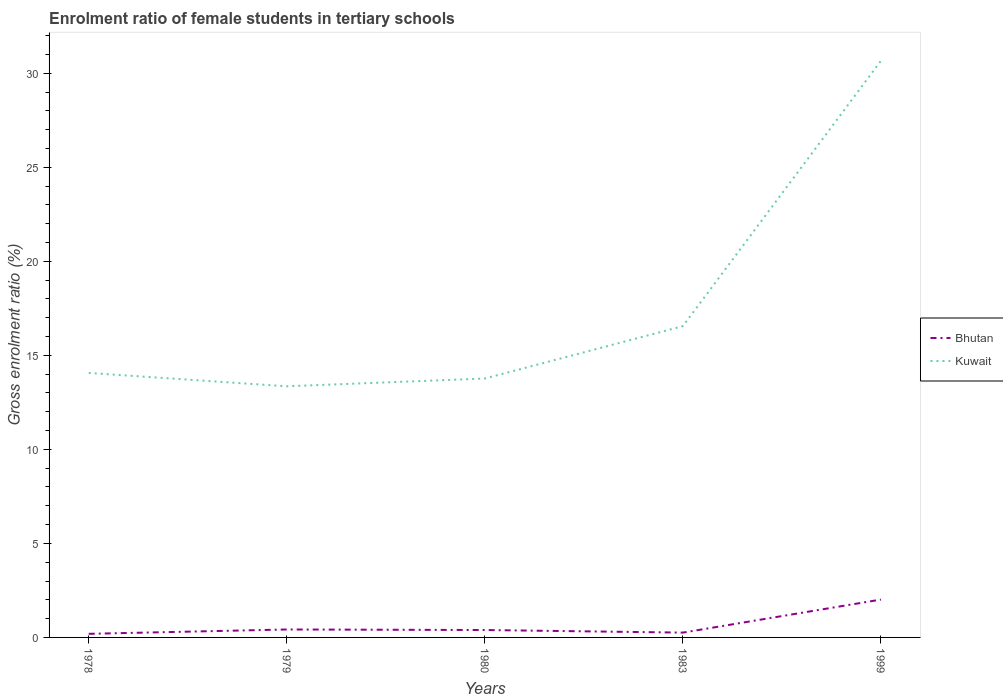How many different coloured lines are there?
Give a very brief answer. 2. Does the line corresponding to Bhutan intersect with the line corresponding to Kuwait?
Your answer should be very brief. No. Is the number of lines equal to the number of legend labels?
Ensure brevity in your answer.  Yes. Across all years, what is the maximum enrolment ratio of female students in tertiary schools in Bhutan?
Keep it short and to the point. 0.19. In which year was the enrolment ratio of female students in tertiary schools in Kuwait maximum?
Give a very brief answer. 1979. What is the total enrolment ratio of female students in tertiary schools in Kuwait in the graph?
Provide a short and direct response. -14.11. What is the difference between the highest and the second highest enrolment ratio of female students in tertiary schools in Bhutan?
Offer a terse response. 1.82. What is the difference between the highest and the lowest enrolment ratio of female students in tertiary schools in Bhutan?
Ensure brevity in your answer.  1. How many lines are there?
Your answer should be compact. 2. What is the difference between two consecutive major ticks on the Y-axis?
Provide a succinct answer. 5. Are the values on the major ticks of Y-axis written in scientific E-notation?
Offer a very short reply. No. Does the graph contain any zero values?
Provide a succinct answer. No. Does the graph contain grids?
Offer a terse response. No. How are the legend labels stacked?
Offer a very short reply. Vertical. What is the title of the graph?
Make the answer very short. Enrolment ratio of female students in tertiary schools. What is the label or title of the X-axis?
Give a very brief answer. Years. What is the Gross enrolment ratio (%) of Bhutan in 1978?
Offer a very short reply. 0.19. What is the Gross enrolment ratio (%) in Kuwait in 1978?
Offer a very short reply. 14.06. What is the Gross enrolment ratio (%) of Bhutan in 1979?
Give a very brief answer. 0.42. What is the Gross enrolment ratio (%) in Kuwait in 1979?
Offer a terse response. 13.35. What is the Gross enrolment ratio (%) of Bhutan in 1980?
Keep it short and to the point. 0.39. What is the Gross enrolment ratio (%) of Kuwait in 1980?
Offer a very short reply. 13.77. What is the Gross enrolment ratio (%) in Bhutan in 1983?
Ensure brevity in your answer.  0.26. What is the Gross enrolment ratio (%) of Kuwait in 1983?
Your answer should be compact. 16.55. What is the Gross enrolment ratio (%) in Bhutan in 1999?
Provide a short and direct response. 2.01. What is the Gross enrolment ratio (%) of Kuwait in 1999?
Keep it short and to the point. 30.66. Across all years, what is the maximum Gross enrolment ratio (%) of Bhutan?
Make the answer very short. 2.01. Across all years, what is the maximum Gross enrolment ratio (%) of Kuwait?
Keep it short and to the point. 30.66. Across all years, what is the minimum Gross enrolment ratio (%) in Bhutan?
Make the answer very short. 0.19. Across all years, what is the minimum Gross enrolment ratio (%) in Kuwait?
Provide a succinct answer. 13.35. What is the total Gross enrolment ratio (%) of Bhutan in the graph?
Your response must be concise. 3.28. What is the total Gross enrolment ratio (%) of Kuwait in the graph?
Offer a terse response. 88.4. What is the difference between the Gross enrolment ratio (%) in Bhutan in 1978 and that in 1979?
Your response must be concise. -0.23. What is the difference between the Gross enrolment ratio (%) of Kuwait in 1978 and that in 1979?
Provide a succinct answer. 0.71. What is the difference between the Gross enrolment ratio (%) in Bhutan in 1978 and that in 1980?
Your answer should be compact. -0.2. What is the difference between the Gross enrolment ratio (%) in Kuwait in 1978 and that in 1980?
Make the answer very short. 0.3. What is the difference between the Gross enrolment ratio (%) in Bhutan in 1978 and that in 1983?
Your answer should be very brief. -0.06. What is the difference between the Gross enrolment ratio (%) in Kuwait in 1978 and that in 1983?
Give a very brief answer. -2.49. What is the difference between the Gross enrolment ratio (%) in Bhutan in 1978 and that in 1999?
Give a very brief answer. -1.82. What is the difference between the Gross enrolment ratio (%) in Kuwait in 1978 and that in 1999?
Provide a succinct answer. -16.59. What is the difference between the Gross enrolment ratio (%) of Bhutan in 1979 and that in 1980?
Your answer should be compact. 0.03. What is the difference between the Gross enrolment ratio (%) in Kuwait in 1979 and that in 1980?
Your answer should be very brief. -0.41. What is the difference between the Gross enrolment ratio (%) in Bhutan in 1979 and that in 1983?
Provide a short and direct response. 0.17. What is the difference between the Gross enrolment ratio (%) in Kuwait in 1979 and that in 1983?
Offer a terse response. -3.2. What is the difference between the Gross enrolment ratio (%) of Bhutan in 1979 and that in 1999?
Offer a very short reply. -1.59. What is the difference between the Gross enrolment ratio (%) in Kuwait in 1979 and that in 1999?
Make the answer very short. -17.3. What is the difference between the Gross enrolment ratio (%) of Bhutan in 1980 and that in 1983?
Provide a succinct answer. 0.14. What is the difference between the Gross enrolment ratio (%) in Kuwait in 1980 and that in 1983?
Provide a succinct answer. -2.79. What is the difference between the Gross enrolment ratio (%) of Bhutan in 1980 and that in 1999?
Your answer should be compact. -1.62. What is the difference between the Gross enrolment ratio (%) of Kuwait in 1980 and that in 1999?
Provide a succinct answer. -16.89. What is the difference between the Gross enrolment ratio (%) in Bhutan in 1983 and that in 1999?
Your response must be concise. -1.76. What is the difference between the Gross enrolment ratio (%) in Kuwait in 1983 and that in 1999?
Provide a succinct answer. -14.11. What is the difference between the Gross enrolment ratio (%) in Bhutan in 1978 and the Gross enrolment ratio (%) in Kuwait in 1979?
Your answer should be compact. -13.16. What is the difference between the Gross enrolment ratio (%) of Bhutan in 1978 and the Gross enrolment ratio (%) of Kuwait in 1980?
Your answer should be very brief. -13.58. What is the difference between the Gross enrolment ratio (%) of Bhutan in 1978 and the Gross enrolment ratio (%) of Kuwait in 1983?
Provide a succinct answer. -16.36. What is the difference between the Gross enrolment ratio (%) in Bhutan in 1978 and the Gross enrolment ratio (%) in Kuwait in 1999?
Offer a very short reply. -30.47. What is the difference between the Gross enrolment ratio (%) of Bhutan in 1979 and the Gross enrolment ratio (%) of Kuwait in 1980?
Keep it short and to the point. -13.35. What is the difference between the Gross enrolment ratio (%) of Bhutan in 1979 and the Gross enrolment ratio (%) of Kuwait in 1983?
Your response must be concise. -16.13. What is the difference between the Gross enrolment ratio (%) of Bhutan in 1979 and the Gross enrolment ratio (%) of Kuwait in 1999?
Your answer should be compact. -30.24. What is the difference between the Gross enrolment ratio (%) in Bhutan in 1980 and the Gross enrolment ratio (%) in Kuwait in 1983?
Your answer should be compact. -16.16. What is the difference between the Gross enrolment ratio (%) in Bhutan in 1980 and the Gross enrolment ratio (%) in Kuwait in 1999?
Your answer should be compact. -30.26. What is the difference between the Gross enrolment ratio (%) of Bhutan in 1983 and the Gross enrolment ratio (%) of Kuwait in 1999?
Your response must be concise. -30.4. What is the average Gross enrolment ratio (%) of Bhutan per year?
Offer a terse response. 0.66. What is the average Gross enrolment ratio (%) of Kuwait per year?
Your response must be concise. 17.68. In the year 1978, what is the difference between the Gross enrolment ratio (%) in Bhutan and Gross enrolment ratio (%) in Kuwait?
Offer a terse response. -13.87. In the year 1979, what is the difference between the Gross enrolment ratio (%) in Bhutan and Gross enrolment ratio (%) in Kuwait?
Make the answer very short. -12.93. In the year 1980, what is the difference between the Gross enrolment ratio (%) in Bhutan and Gross enrolment ratio (%) in Kuwait?
Offer a terse response. -13.37. In the year 1983, what is the difference between the Gross enrolment ratio (%) in Bhutan and Gross enrolment ratio (%) in Kuwait?
Provide a succinct answer. -16.3. In the year 1999, what is the difference between the Gross enrolment ratio (%) in Bhutan and Gross enrolment ratio (%) in Kuwait?
Provide a succinct answer. -28.65. What is the ratio of the Gross enrolment ratio (%) of Bhutan in 1978 to that in 1979?
Offer a very short reply. 0.45. What is the ratio of the Gross enrolment ratio (%) of Kuwait in 1978 to that in 1979?
Keep it short and to the point. 1.05. What is the ratio of the Gross enrolment ratio (%) in Bhutan in 1978 to that in 1980?
Your response must be concise. 0.49. What is the ratio of the Gross enrolment ratio (%) in Kuwait in 1978 to that in 1980?
Ensure brevity in your answer.  1.02. What is the ratio of the Gross enrolment ratio (%) in Bhutan in 1978 to that in 1983?
Your response must be concise. 0.75. What is the ratio of the Gross enrolment ratio (%) in Kuwait in 1978 to that in 1983?
Your answer should be very brief. 0.85. What is the ratio of the Gross enrolment ratio (%) of Bhutan in 1978 to that in 1999?
Keep it short and to the point. 0.1. What is the ratio of the Gross enrolment ratio (%) of Kuwait in 1978 to that in 1999?
Offer a terse response. 0.46. What is the ratio of the Gross enrolment ratio (%) in Bhutan in 1979 to that in 1980?
Your answer should be compact. 1.07. What is the ratio of the Gross enrolment ratio (%) in Bhutan in 1979 to that in 1983?
Offer a very short reply. 1.65. What is the ratio of the Gross enrolment ratio (%) in Kuwait in 1979 to that in 1983?
Give a very brief answer. 0.81. What is the ratio of the Gross enrolment ratio (%) in Bhutan in 1979 to that in 1999?
Your answer should be very brief. 0.21. What is the ratio of the Gross enrolment ratio (%) of Kuwait in 1979 to that in 1999?
Your response must be concise. 0.44. What is the ratio of the Gross enrolment ratio (%) of Bhutan in 1980 to that in 1983?
Ensure brevity in your answer.  1.54. What is the ratio of the Gross enrolment ratio (%) in Kuwait in 1980 to that in 1983?
Provide a succinct answer. 0.83. What is the ratio of the Gross enrolment ratio (%) of Bhutan in 1980 to that in 1999?
Give a very brief answer. 0.2. What is the ratio of the Gross enrolment ratio (%) in Kuwait in 1980 to that in 1999?
Your answer should be compact. 0.45. What is the ratio of the Gross enrolment ratio (%) of Bhutan in 1983 to that in 1999?
Your response must be concise. 0.13. What is the ratio of the Gross enrolment ratio (%) in Kuwait in 1983 to that in 1999?
Give a very brief answer. 0.54. What is the difference between the highest and the second highest Gross enrolment ratio (%) in Bhutan?
Provide a succinct answer. 1.59. What is the difference between the highest and the second highest Gross enrolment ratio (%) of Kuwait?
Offer a terse response. 14.11. What is the difference between the highest and the lowest Gross enrolment ratio (%) in Bhutan?
Your answer should be compact. 1.82. What is the difference between the highest and the lowest Gross enrolment ratio (%) in Kuwait?
Ensure brevity in your answer.  17.3. 